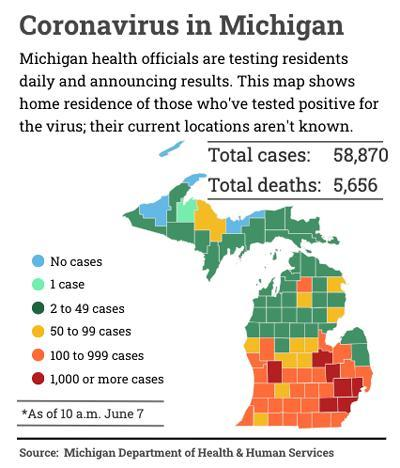By which colour has 50 to 99 cases been represented- yellow, red or blue?
Answer the question with a short phrase. yellow What does red colour in the map represent? 1,000 or more cases How many places have 1000 or more cases? 7 Out of the total cases how many people are alive? 53,214 